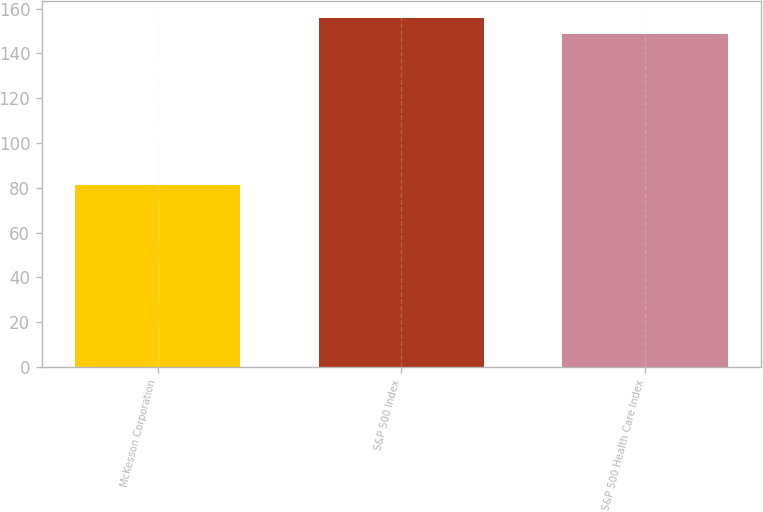Convert chart to OTSL. <chart><loc_0><loc_0><loc_500><loc_500><bar_chart><fcel>McKesson Corporation<fcel>S&P 500 Index<fcel>S&P 500 Health Care Index<nl><fcel>81.17<fcel>155.78<fcel>148.57<nl></chart> 